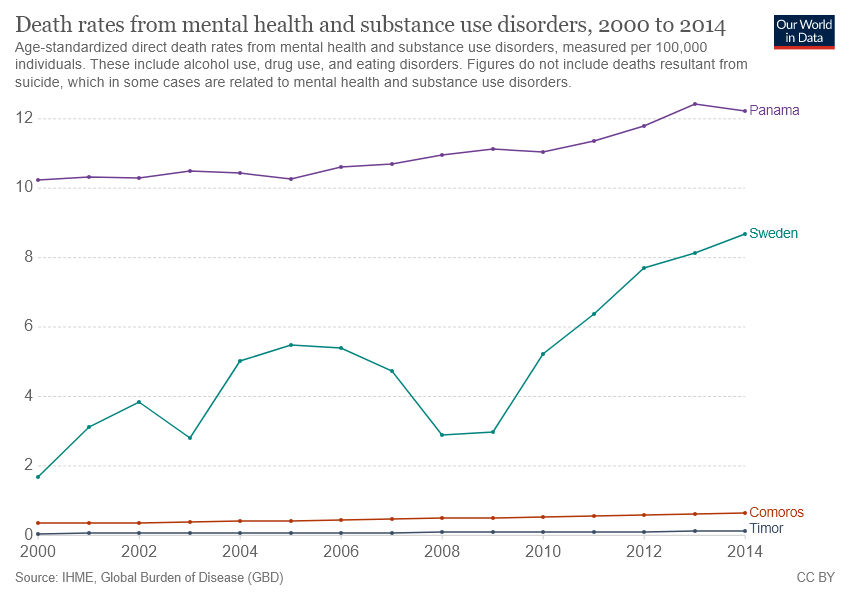Draw attention to some important aspects in this diagram. According to the available information, the death rate from mental health in Comoros was higher than in Timor. Panama has the highest recorded number of death rates from mental health conditions, according to recent data. 